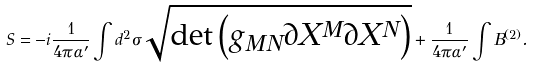<formula> <loc_0><loc_0><loc_500><loc_500>S = - i \frac { 1 } { 4 \pi \alpha ^ { \prime } } \int d ^ { 2 } \sigma \sqrt { \det \left ( g _ { M N } \partial X ^ { M } \partial X ^ { N } \right ) } + \frac { 1 } { 4 \pi \alpha ^ { \prime } } \int B ^ { ( 2 ) } .</formula> 